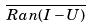<formula> <loc_0><loc_0><loc_500><loc_500>\overline { R a n ( I - U ) }</formula> 